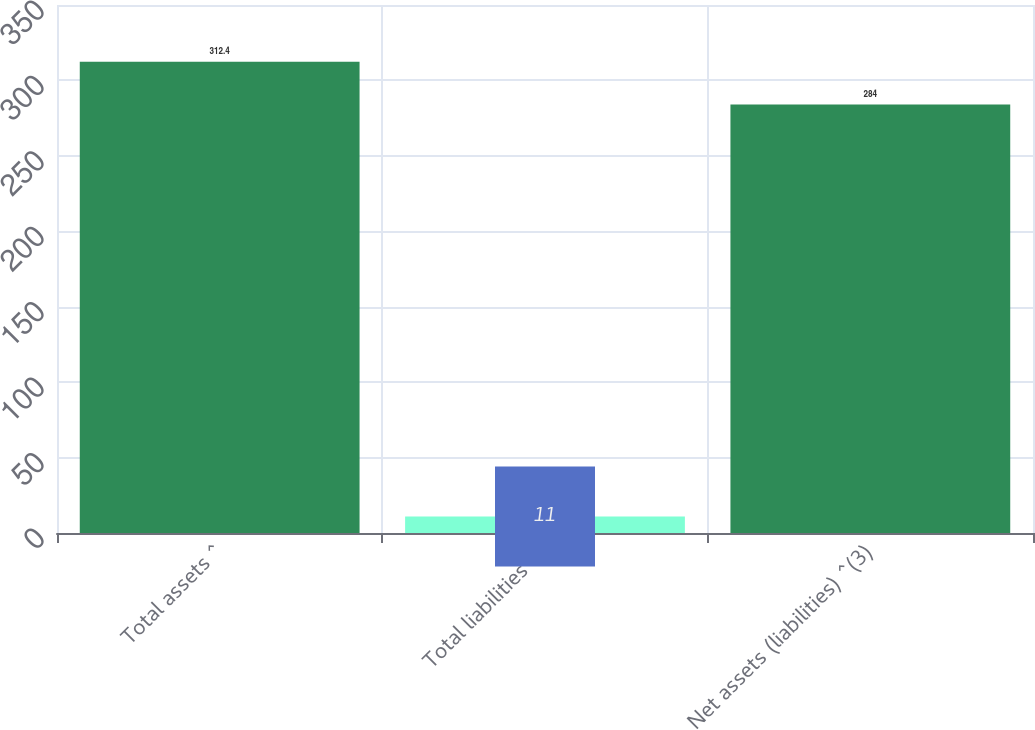Convert chart. <chart><loc_0><loc_0><loc_500><loc_500><bar_chart><fcel>Total assets ^<fcel>Total liabilities^ ^<fcel>Net assets (liabilities) ^(3)<nl><fcel>312.4<fcel>11<fcel>284<nl></chart> 